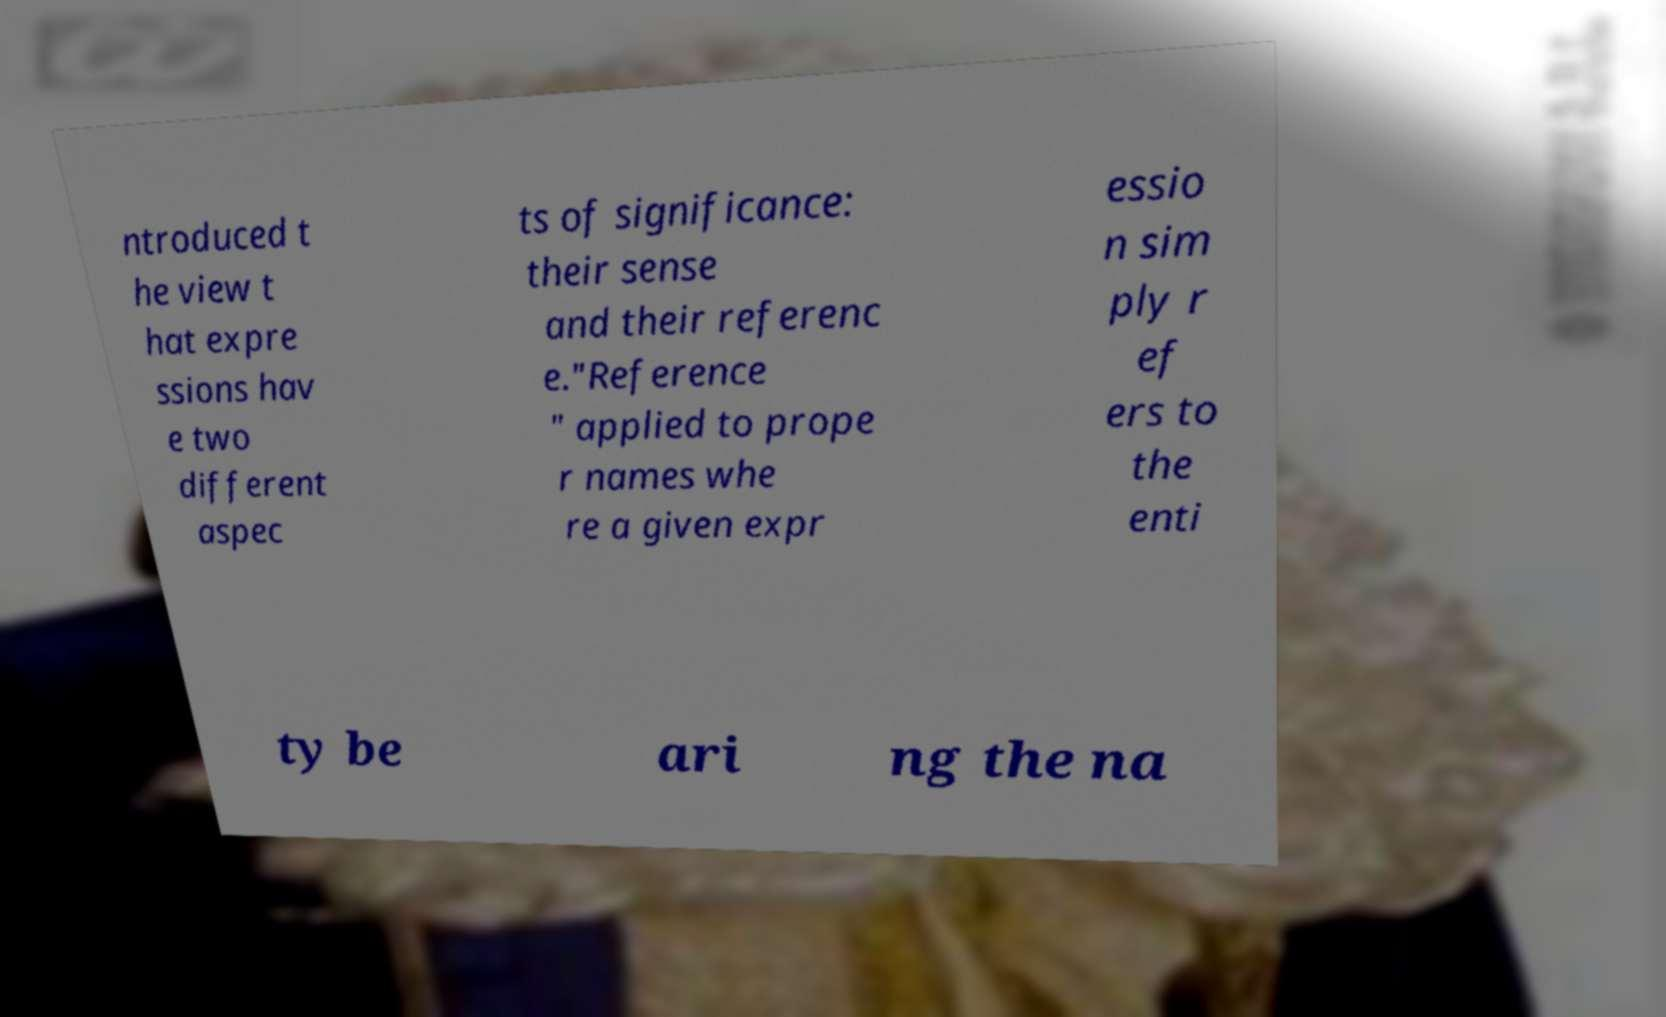Please identify and transcribe the text found in this image. ntroduced t he view t hat expre ssions hav e two different aspec ts of significance: their sense and their referenc e."Reference " applied to prope r names whe re a given expr essio n sim ply r ef ers to the enti ty be ari ng the na 